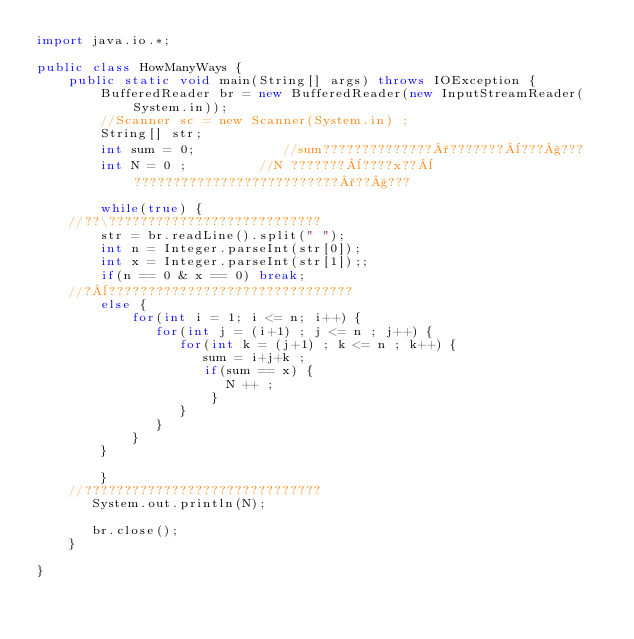<code> <loc_0><loc_0><loc_500><loc_500><_Java_>import java.io.*;

public class HowManyWays {
	public static void main(String[] args) throws IOException {
		BufferedReader br = new BufferedReader(new InputStreamReader(System.in));
		//Scanner sc = new Scanner(System.in) ;
        String[] str;
		int sum = 0;           //sum??????????????°???????¨???§???
		int N = 0 ;         //N ???????¨????x??¨??????????????????????????°??§???
		
		while(true) {
	//??\???????????????????????????
		str = br.readLine().split(" ");	
		int n = Integer.parseInt(str[0]);
		int x = Integer.parseInt(str[1]);;
		if(n == 0 & x == 0) break;
	//?¨???????????????????????????????	   
		else {
			for(int i = 1; i <= n; i++) {
			   for(int j = (i+1) ; j <= n ; j++) {
				  for(int k = (j+1) ; k <= n ; k++) {
					 sum = i+j+k ;
					 if(sum == x) {
						N ++ ;
					  }  
				  }
			   }
		    }
		}
			
	    }
	//??????????????????????????????
	   System.out.println(N);
 
	   br.close();
	}

}</code> 